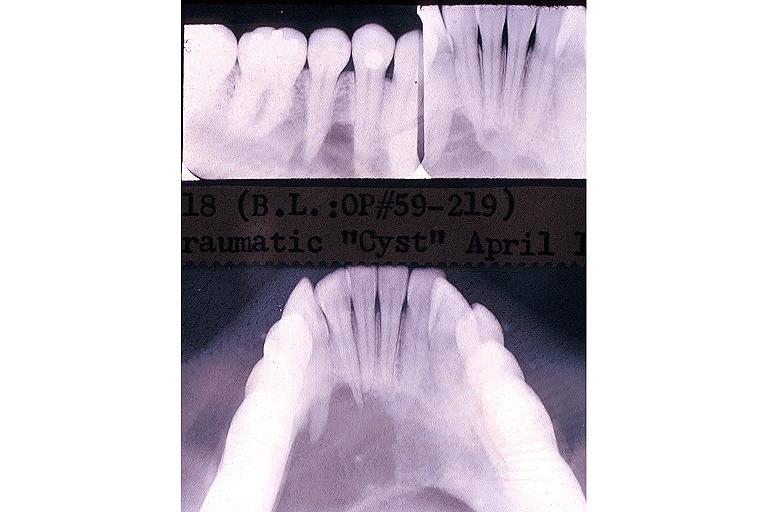where is this?
Answer the question using a single word or phrase. Oral 